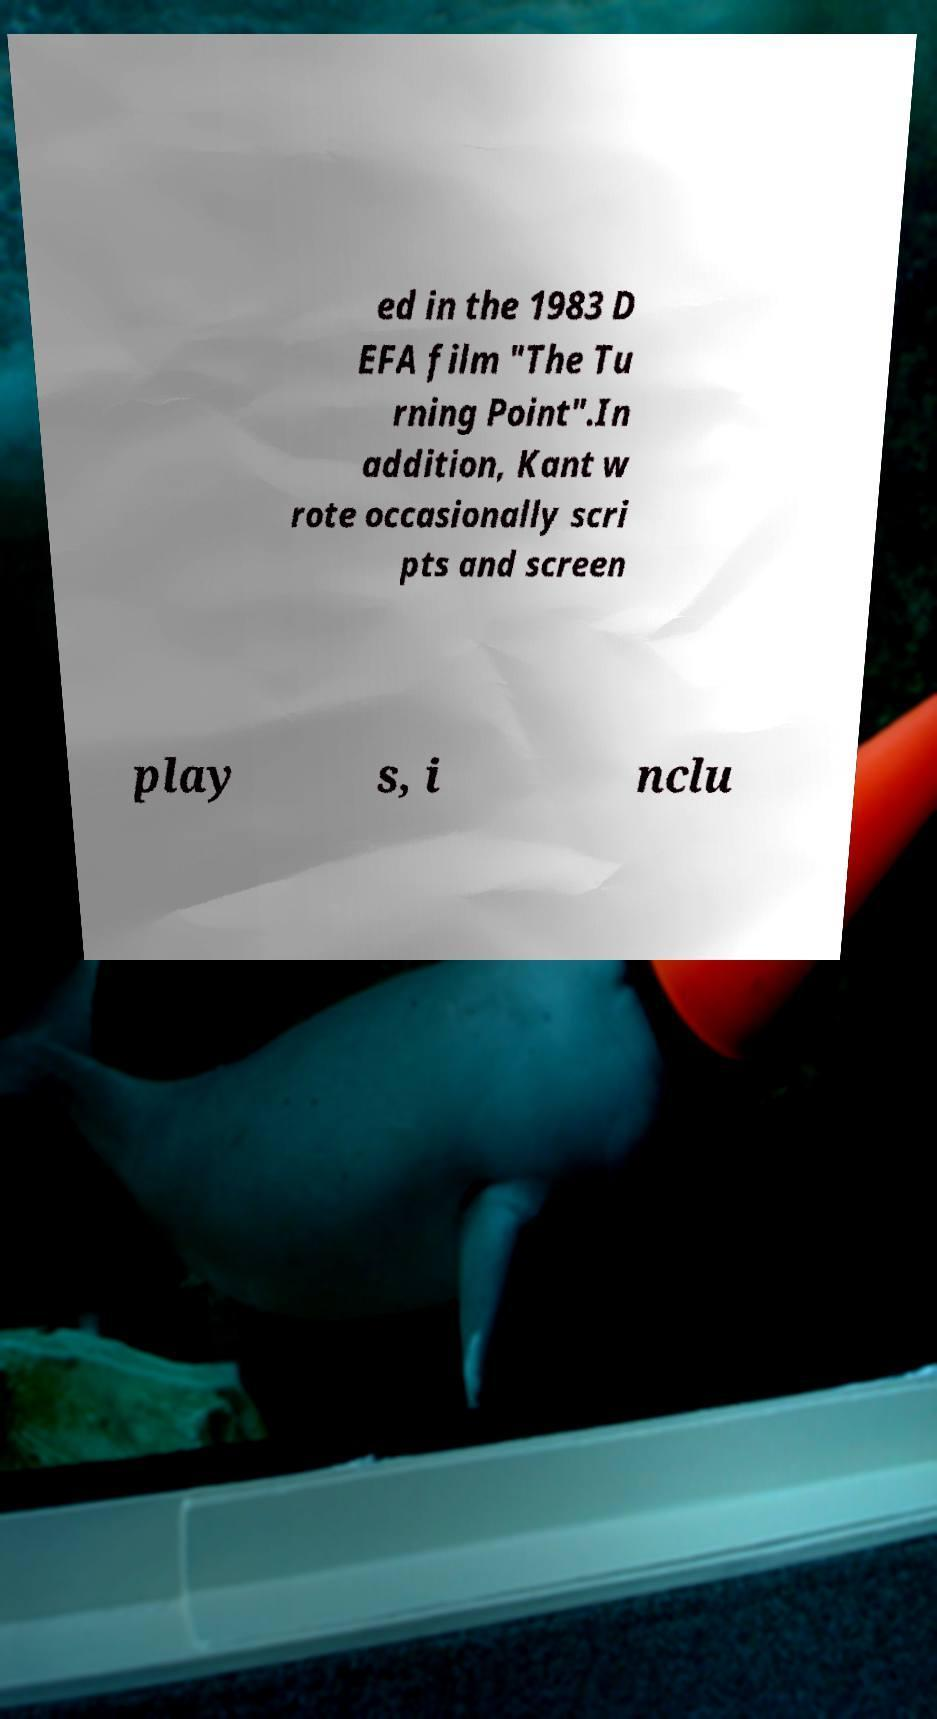Could you extract and type out the text from this image? ed in the 1983 D EFA film "The Tu rning Point".In addition, Kant w rote occasionally scri pts and screen play s, i nclu 